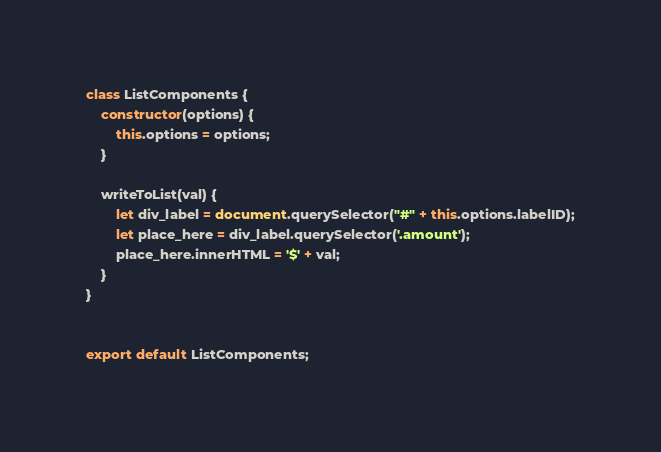Convert code to text. <code><loc_0><loc_0><loc_500><loc_500><_JavaScript_>class ListComponents {
    constructor(options) {
        this.options = options;
    }

    writeToList(val) {
        let div_label = document.querySelector("#" + this.options.labelID);
        let place_here = div_label.querySelector('.amount');
        place_here.innerHTML = '$' + val;
    }
}


export default ListComponents;</code> 